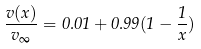Convert formula to latex. <formula><loc_0><loc_0><loc_500><loc_500>\frac { v ( x ) } { v _ { \infty } } = 0 . 0 1 + 0 . 9 9 ( 1 - \frac { 1 } { x } )</formula> 